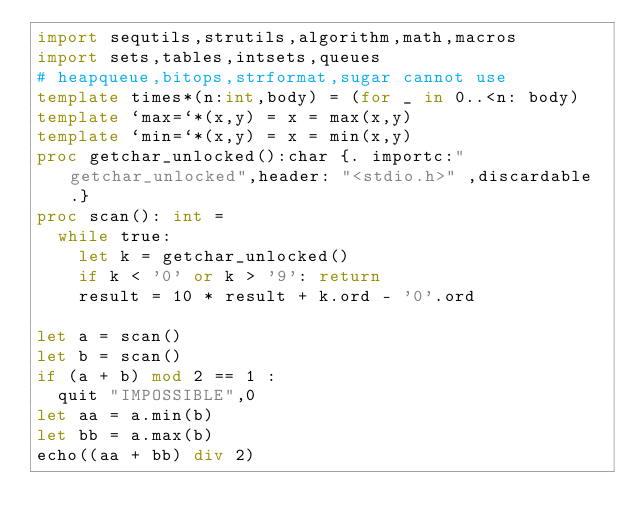Convert code to text. <code><loc_0><loc_0><loc_500><loc_500><_Nim_>import sequtils,strutils,algorithm,math,macros
import sets,tables,intsets,queues
# heapqueue,bitops,strformat,sugar cannot use
template times*(n:int,body) = (for _ in 0..<n: body)
template `max=`*(x,y) = x = max(x,y)
template `min=`*(x,y) = x = min(x,y)
proc getchar_unlocked():char {. importc:"getchar_unlocked",header: "<stdio.h>" ,discardable.}
proc scan(): int =
  while true:
    let k = getchar_unlocked()
    if k < '0' or k > '9': return
    result = 10 * result + k.ord - '0'.ord

let a = scan()
let b = scan()
if (a + b) mod 2 == 1 :
  quit "IMPOSSIBLE",0
let aa = a.min(b)
let bb = a.max(b)
echo((aa + bb) div 2)
</code> 